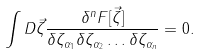Convert formula to latex. <formula><loc_0><loc_0><loc_500><loc_500>\int D \vec { \zeta } \frac { \delta ^ { n } F [ \vec { \zeta } ] } { \delta \zeta _ { \alpha _ { 1 } } \delta \zeta _ { \alpha _ { 2 } } \dots \delta \zeta _ { \alpha _ { n } } } = 0 .</formula> 